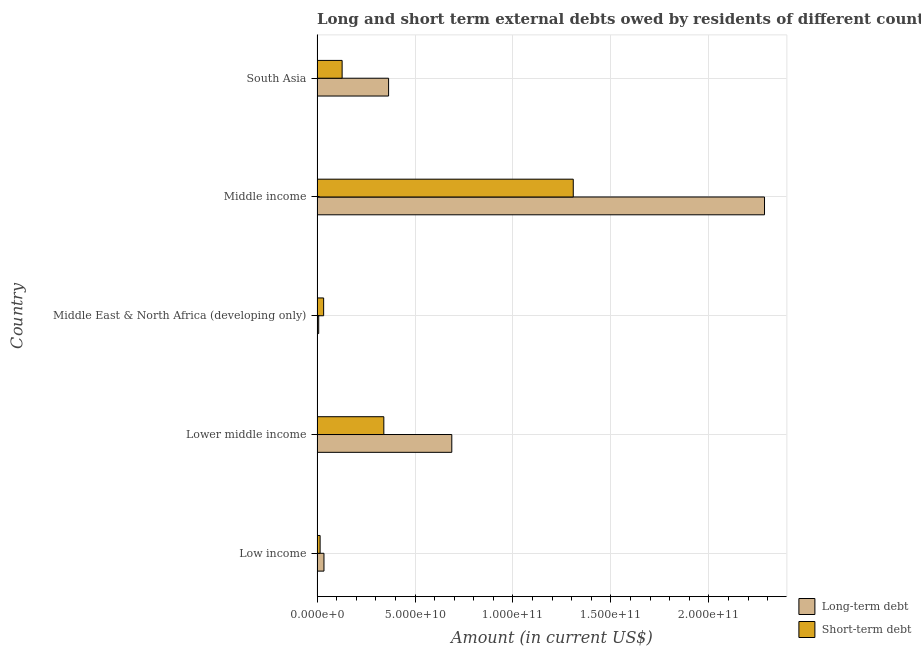Are the number of bars on each tick of the Y-axis equal?
Your answer should be very brief. Yes. How many bars are there on the 3rd tick from the top?
Ensure brevity in your answer.  2. What is the label of the 4th group of bars from the top?
Your response must be concise. Lower middle income. In how many cases, is the number of bars for a given country not equal to the number of legend labels?
Provide a short and direct response. 0. What is the long-term debts owed by residents in Middle East & North Africa (developing only)?
Your response must be concise. 8.44e+08. Across all countries, what is the maximum short-term debts owed by residents?
Your response must be concise. 1.31e+11. Across all countries, what is the minimum short-term debts owed by residents?
Provide a short and direct response. 1.56e+09. In which country was the long-term debts owed by residents minimum?
Offer a very short reply. Middle East & North Africa (developing only). What is the total long-term debts owed by residents in the graph?
Make the answer very short. 3.38e+11. What is the difference between the long-term debts owed by residents in Lower middle income and that in Middle East & North Africa (developing only)?
Provide a short and direct response. 6.79e+1. What is the difference between the long-term debts owed by residents in Middle income and the short-term debts owed by residents in Low income?
Make the answer very short. 2.27e+11. What is the average long-term debts owed by residents per country?
Provide a short and direct response. 6.76e+1. What is the difference between the short-term debts owed by residents and long-term debts owed by residents in Low income?
Offer a very short reply. -1.97e+09. What is the ratio of the long-term debts owed by residents in Low income to that in South Asia?
Your answer should be compact. 0.1. Is the difference between the short-term debts owed by residents in Lower middle income and South Asia greater than the difference between the long-term debts owed by residents in Lower middle income and South Asia?
Make the answer very short. No. What is the difference between the highest and the second highest long-term debts owed by residents?
Offer a terse response. 1.60e+11. What is the difference between the highest and the lowest short-term debts owed by residents?
Provide a short and direct response. 1.29e+11. Is the sum of the short-term debts owed by residents in Lower middle income and Middle East & North Africa (developing only) greater than the maximum long-term debts owed by residents across all countries?
Keep it short and to the point. No. What does the 2nd bar from the top in Low income represents?
Your answer should be compact. Long-term debt. What does the 2nd bar from the bottom in Middle East & North Africa (developing only) represents?
Your answer should be compact. Short-term debt. Are all the bars in the graph horizontal?
Offer a terse response. Yes. What is the difference between two consecutive major ticks on the X-axis?
Provide a succinct answer. 5.00e+1. Are the values on the major ticks of X-axis written in scientific E-notation?
Ensure brevity in your answer.  Yes. Where does the legend appear in the graph?
Give a very brief answer. Bottom right. What is the title of the graph?
Make the answer very short. Long and short term external debts owed by residents of different countries. Does "External balance on goods" appear as one of the legend labels in the graph?
Provide a short and direct response. No. What is the label or title of the X-axis?
Provide a short and direct response. Amount (in current US$). What is the Amount (in current US$) of Long-term debt in Low income?
Ensure brevity in your answer.  3.53e+09. What is the Amount (in current US$) in Short-term debt in Low income?
Keep it short and to the point. 1.56e+09. What is the Amount (in current US$) of Long-term debt in Lower middle income?
Keep it short and to the point. 6.88e+1. What is the Amount (in current US$) of Short-term debt in Lower middle income?
Provide a succinct answer. 3.41e+1. What is the Amount (in current US$) in Long-term debt in Middle East & North Africa (developing only)?
Provide a short and direct response. 8.44e+08. What is the Amount (in current US$) of Short-term debt in Middle East & North Africa (developing only)?
Your response must be concise. 3.36e+09. What is the Amount (in current US$) of Long-term debt in Middle income?
Provide a succinct answer. 2.28e+11. What is the Amount (in current US$) in Short-term debt in Middle income?
Give a very brief answer. 1.31e+11. What is the Amount (in current US$) of Long-term debt in South Asia?
Keep it short and to the point. 3.65e+1. What is the Amount (in current US$) of Short-term debt in South Asia?
Offer a terse response. 1.28e+1. Across all countries, what is the maximum Amount (in current US$) in Long-term debt?
Offer a terse response. 2.28e+11. Across all countries, what is the maximum Amount (in current US$) in Short-term debt?
Ensure brevity in your answer.  1.31e+11. Across all countries, what is the minimum Amount (in current US$) of Long-term debt?
Your answer should be compact. 8.44e+08. Across all countries, what is the minimum Amount (in current US$) of Short-term debt?
Ensure brevity in your answer.  1.56e+09. What is the total Amount (in current US$) in Long-term debt in the graph?
Your response must be concise. 3.38e+11. What is the total Amount (in current US$) of Short-term debt in the graph?
Ensure brevity in your answer.  1.83e+11. What is the difference between the Amount (in current US$) of Long-term debt in Low income and that in Lower middle income?
Offer a very short reply. -6.53e+1. What is the difference between the Amount (in current US$) in Short-term debt in Low income and that in Lower middle income?
Provide a succinct answer. -3.25e+1. What is the difference between the Amount (in current US$) in Long-term debt in Low income and that in Middle East & North Africa (developing only)?
Offer a very short reply. 2.68e+09. What is the difference between the Amount (in current US$) of Short-term debt in Low income and that in Middle East & North Africa (developing only)?
Give a very brief answer. -1.81e+09. What is the difference between the Amount (in current US$) in Long-term debt in Low income and that in Middle income?
Your response must be concise. -2.25e+11. What is the difference between the Amount (in current US$) in Short-term debt in Low income and that in Middle income?
Provide a short and direct response. -1.29e+11. What is the difference between the Amount (in current US$) of Long-term debt in Low income and that in South Asia?
Your response must be concise. -3.30e+1. What is the difference between the Amount (in current US$) of Short-term debt in Low income and that in South Asia?
Your answer should be compact. -1.12e+1. What is the difference between the Amount (in current US$) of Long-term debt in Lower middle income and that in Middle East & North Africa (developing only)?
Your answer should be compact. 6.79e+1. What is the difference between the Amount (in current US$) in Short-term debt in Lower middle income and that in Middle East & North Africa (developing only)?
Offer a terse response. 3.07e+1. What is the difference between the Amount (in current US$) of Long-term debt in Lower middle income and that in Middle income?
Provide a succinct answer. -1.60e+11. What is the difference between the Amount (in current US$) of Short-term debt in Lower middle income and that in Middle income?
Ensure brevity in your answer.  -9.67e+1. What is the difference between the Amount (in current US$) in Long-term debt in Lower middle income and that in South Asia?
Give a very brief answer. 3.23e+1. What is the difference between the Amount (in current US$) of Short-term debt in Lower middle income and that in South Asia?
Your response must be concise. 2.13e+1. What is the difference between the Amount (in current US$) in Long-term debt in Middle East & North Africa (developing only) and that in Middle income?
Offer a very short reply. -2.28e+11. What is the difference between the Amount (in current US$) of Short-term debt in Middle East & North Africa (developing only) and that in Middle income?
Your response must be concise. -1.27e+11. What is the difference between the Amount (in current US$) in Long-term debt in Middle East & North Africa (developing only) and that in South Asia?
Make the answer very short. -3.57e+1. What is the difference between the Amount (in current US$) in Short-term debt in Middle East & North Africa (developing only) and that in South Asia?
Offer a very short reply. -9.44e+09. What is the difference between the Amount (in current US$) of Long-term debt in Middle income and that in South Asia?
Your response must be concise. 1.92e+11. What is the difference between the Amount (in current US$) in Short-term debt in Middle income and that in South Asia?
Provide a succinct answer. 1.18e+11. What is the difference between the Amount (in current US$) in Long-term debt in Low income and the Amount (in current US$) in Short-term debt in Lower middle income?
Offer a terse response. -3.06e+1. What is the difference between the Amount (in current US$) in Long-term debt in Low income and the Amount (in current US$) in Short-term debt in Middle East & North Africa (developing only)?
Make the answer very short. 1.62e+08. What is the difference between the Amount (in current US$) of Long-term debt in Low income and the Amount (in current US$) of Short-term debt in Middle income?
Your response must be concise. -1.27e+11. What is the difference between the Amount (in current US$) in Long-term debt in Low income and the Amount (in current US$) in Short-term debt in South Asia?
Provide a succinct answer. -9.27e+09. What is the difference between the Amount (in current US$) of Long-term debt in Lower middle income and the Amount (in current US$) of Short-term debt in Middle East & North Africa (developing only)?
Give a very brief answer. 6.54e+1. What is the difference between the Amount (in current US$) in Long-term debt in Lower middle income and the Amount (in current US$) in Short-term debt in Middle income?
Your response must be concise. -6.20e+1. What is the difference between the Amount (in current US$) in Long-term debt in Lower middle income and the Amount (in current US$) in Short-term debt in South Asia?
Offer a terse response. 5.60e+1. What is the difference between the Amount (in current US$) in Long-term debt in Middle East & North Africa (developing only) and the Amount (in current US$) in Short-term debt in Middle income?
Offer a terse response. -1.30e+11. What is the difference between the Amount (in current US$) of Long-term debt in Middle East & North Africa (developing only) and the Amount (in current US$) of Short-term debt in South Asia?
Ensure brevity in your answer.  -1.20e+1. What is the difference between the Amount (in current US$) of Long-term debt in Middle income and the Amount (in current US$) of Short-term debt in South Asia?
Your response must be concise. 2.16e+11. What is the average Amount (in current US$) of Long-term debt per country?
Your response must be concise. 6.76e+1. What is the average Amount (in current US$) in Short-term debt per country?
Keep it short and to the point. 3.65e+1. What is the difference between the Amount (in current US$) in Long-term debt and Amount (in current US$) in Short-term debt in Low income?
Provide a succinct answer. 1.97e+09. What is the difference between the Amount (in current US$) of Long-term debt and Amount (in current US$) of Short-term debt in Lower middle income?
Your answer should be very brief. 3.47e+1. What is the difference between the Amount (in current US$) of Long-term debt and Amount (in current US$) of Short-term debt in Middle East & North Africa (developing only)?
Give a very brief answer. -2.52e+09. What is the difference between the Amount (in current US$) of Long-term debt and Amount (in current US$) of Short-term debt in Middle income?
Make the answer very short. 9.76e+1. What is the difference between the Amount (in current US$) of Long-term debt and Amount (in current US$) of Short-term debt in South Asia?
Your answer should be very brief. 2.37e+1. What is the ratio of the Amount (in current US$) of Long-term debt in Low income to that in Lower middle income?
Offer a terse response. 0.05. What is the ratio of the Amount (in current US$) in Short-term debt in Low income to that in Lower middle income?
Give a very brief answer. 0.05. What is the ratio of the Amount (in current US$) of Long-term debt in Low income to that in Middle East & North Africa (developing only)?
Provide a short and direct response. 4.18. What is the ratio of the Amount (in current US$) in Short-term debt in Low income to that in Middle East & North Africa (developing only)?
Provide a succinct answer. 0.46. What is the ratio of the Amount (in current US$) of Long-term debt in Low income to that in Middle income?
Ensure brevity in your answer.  0.02. What is the ratio of the Amount (in current US$) in Short-term debt in Low income to that in Middle income?
Offer a very short reply. 0.01. What is the ratio of the Amount (in current US$) of Long-term debt in Low income to that in South Asia?
Keep it short and to the point. 0.1. What is the ratio of the Amount (in current US$) of Short-term debt in Low income to that in South Asia?
Offer a terse response. 0.12. What is the ratio of the Amount (in current US$) of Long-term debt in Lower middle income to that in Middle East & North Africa (developing only)?
Give a very brief answer. 81.46. What is the ratio of the Amount (in current US$) in Short-term debt in Lower middle income to that in Middle East & North Africa (developing only)?
Ensure brevity in your answer.  10.13. What is the ratio of the Amount (in current US$) of Long-term debt in Lower middle income to that in Middle income?
Offer a terse response. 0.3. What is the ratio of the Amount (in current US$) in Short-term debt in Lower middle income to that in Middle income?
Make the answer very short. 0.26. What is the ratio of the Amount (in current US$) in Long-term debt in Lower middle income to that in South Asia?
Your response must be concise. 1.88. What is the ratio of the Amount (in current US$) of Short-term debt in Lower middle income to that in South Asia?
Give a very brief answer. 2.66. What is the ratio of the Amount (in current US$) of Long-term debt in Middle East & North Africa (developing only) to that in Middle income?
Your answer should be very brief. 0. What is the ratio of the Amount (in current US$) of Short-term debt in Middle East & North Africa (developing only) to that in Middle income?
Make the answer very short. 0.03. What is the ratio of the Amount (in current US$) of Long-term debt in Middle East & North Africa (developing only) to that in South Asia?
Ensure brevity in your answer.  0.02. What is the ratio of the Amount (in current US$) of Short-term debt in Middle East & North Africa (developing only) to that in South Asia?
Your answer should be compact. 0.26. What is the ratio of the Amount (in current US$) of Long-term debt in Middle income to that in South Asia?
Your answer should be compact. 6.25. What is the ratio of the Amount (in current US$) of Short-term debt in Middle income to that in South Asia?
Provide a short and direct response. 10.22. What is the difference between the highest and the second highest Amount (in current US$) of Long-term debt?
Your answer should be very brief. 1.60e+11. What is the difference between the highest and the second highest Amount (in current US$) in Short-term debt?
Offer a terse response. 9.67e+1. What is the difference between the highest and the lowest Amount (in current US$) in Long-term debt?
Offer a terse response. 2.28e+11. What is the difference between the highest and the lowest Amount (in current US$) of Short-term debt?
Offer a very short reply. 1.29e+11. 